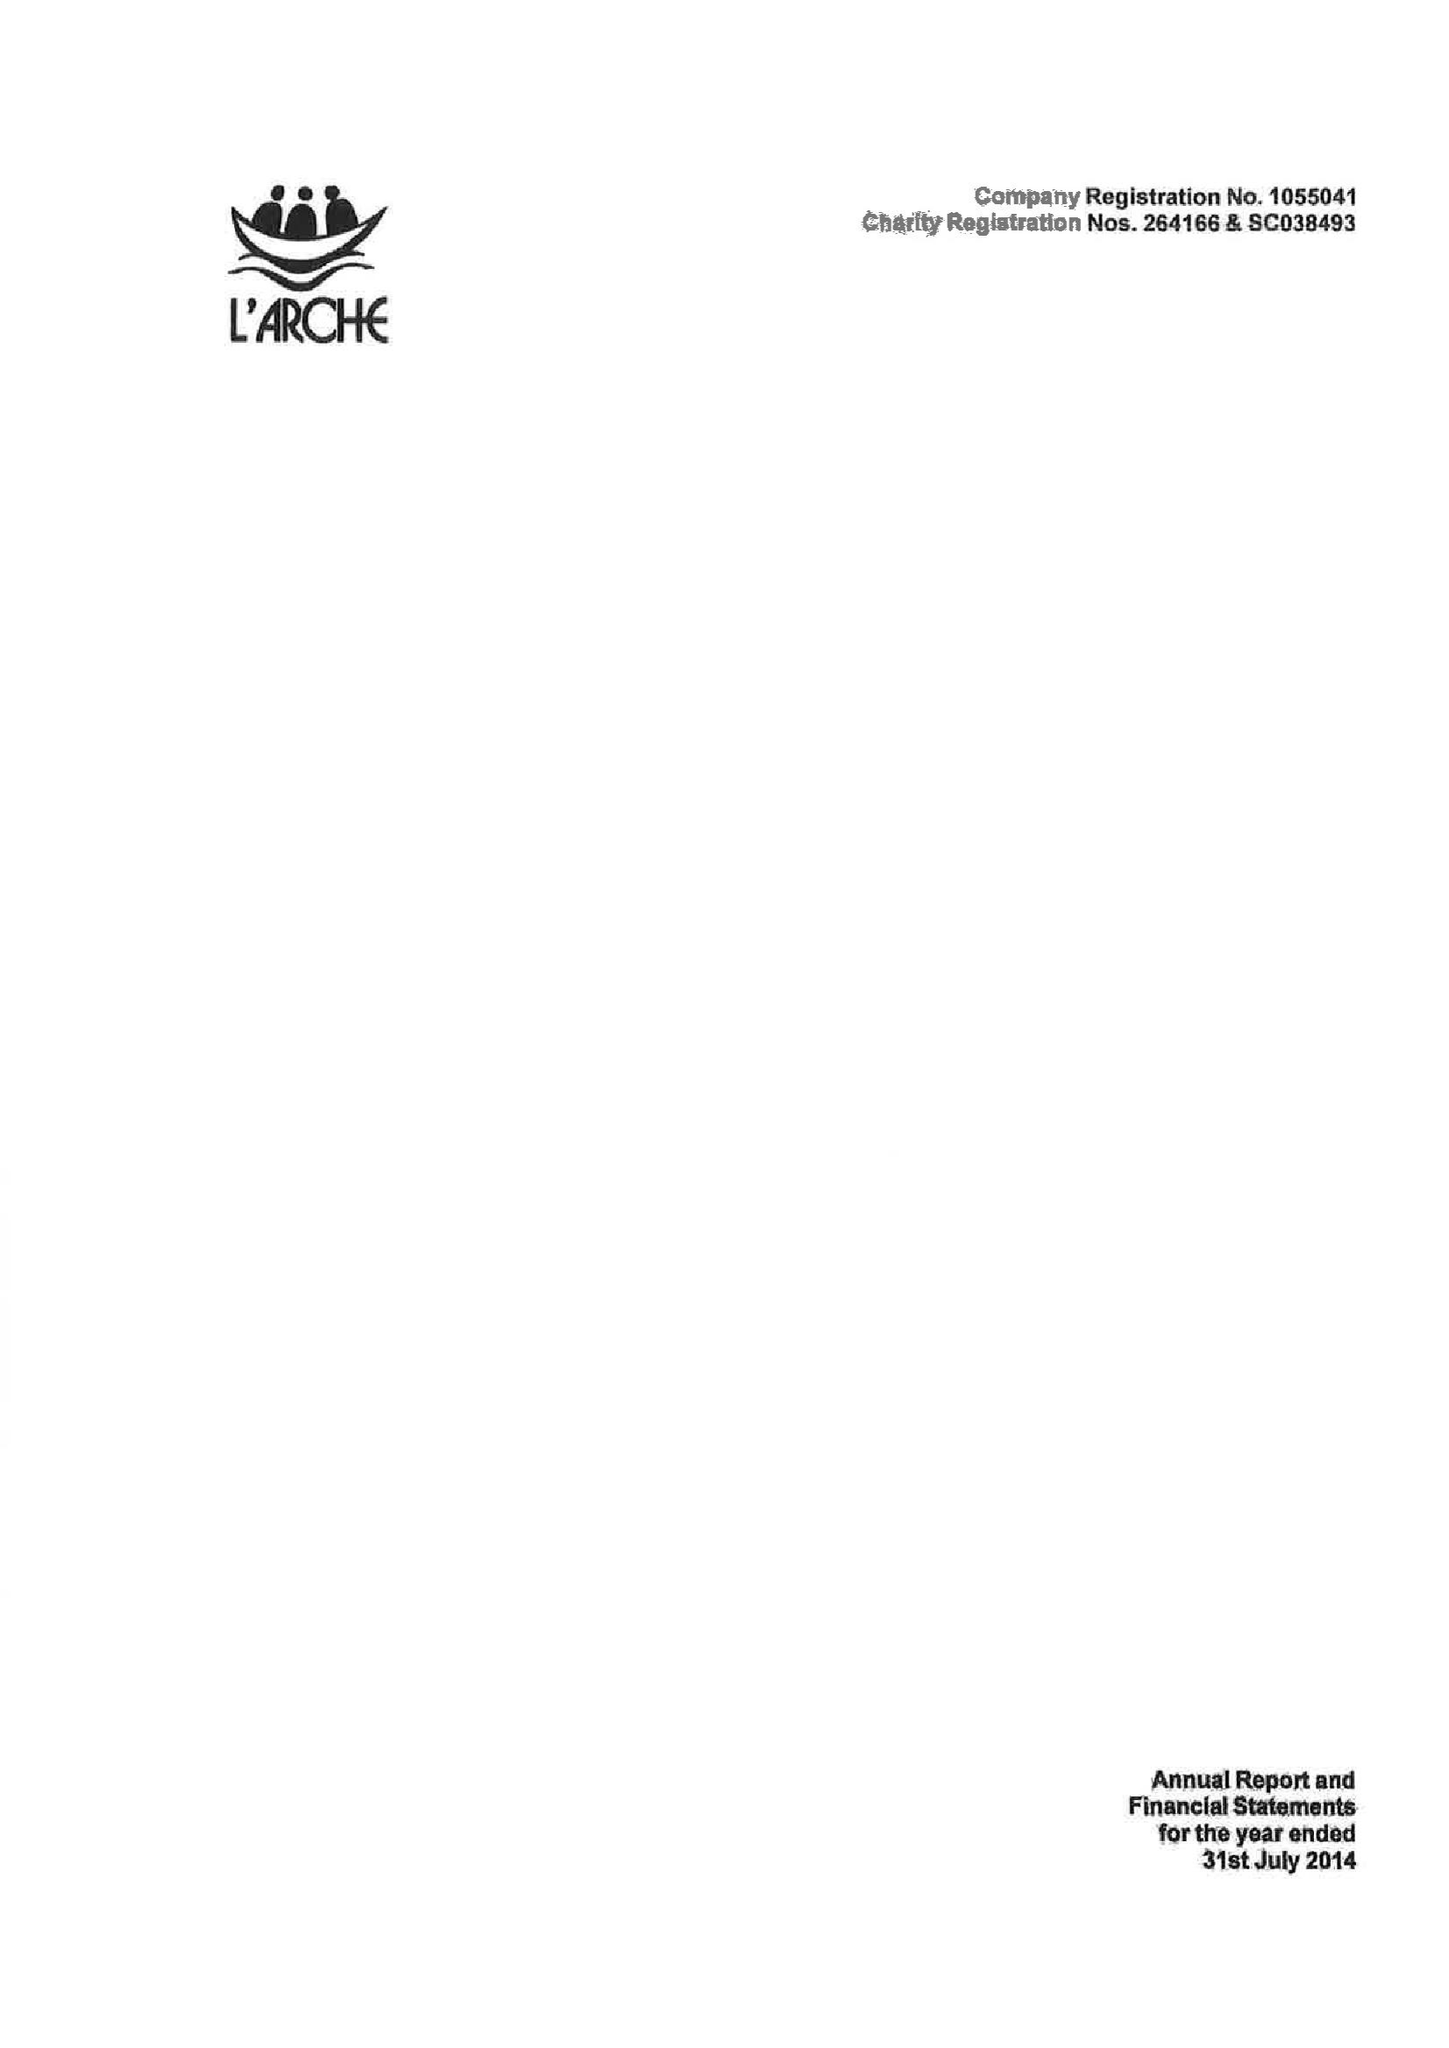What is the value for the address__street_line?
Answer the question using a single word or phrase. 10 BRIGGATE 